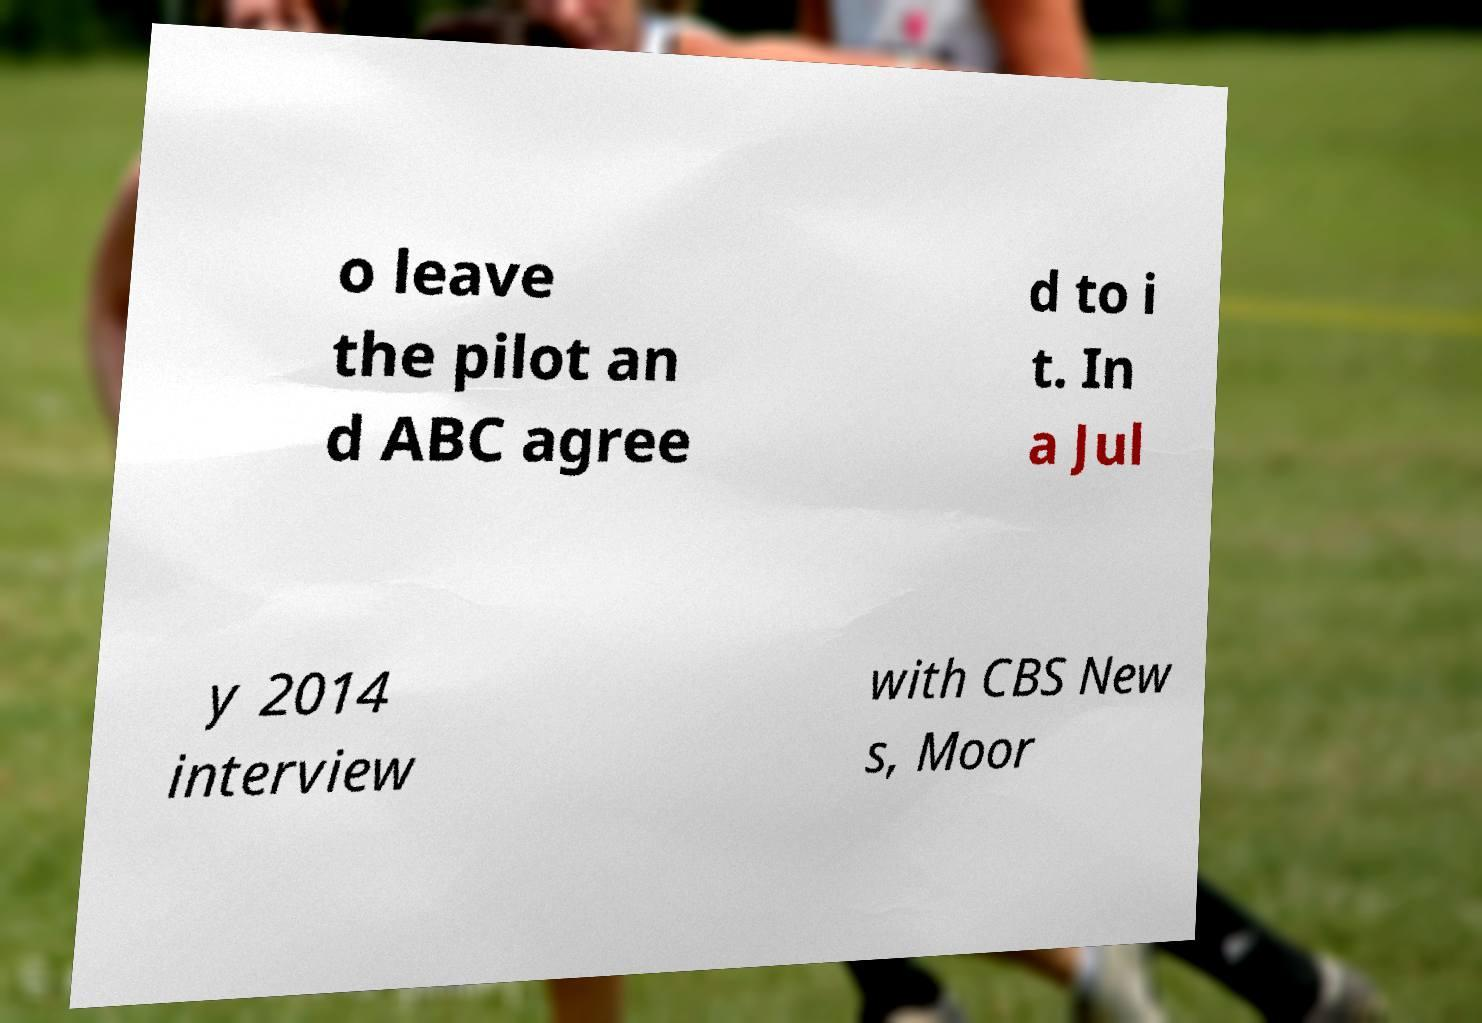Could you assist in decoding the text presented in this image and type it out clearly? o leave the pilot an d ABC agree d to i t. In a Jul y 2014 interview with CBS New s, Moor 